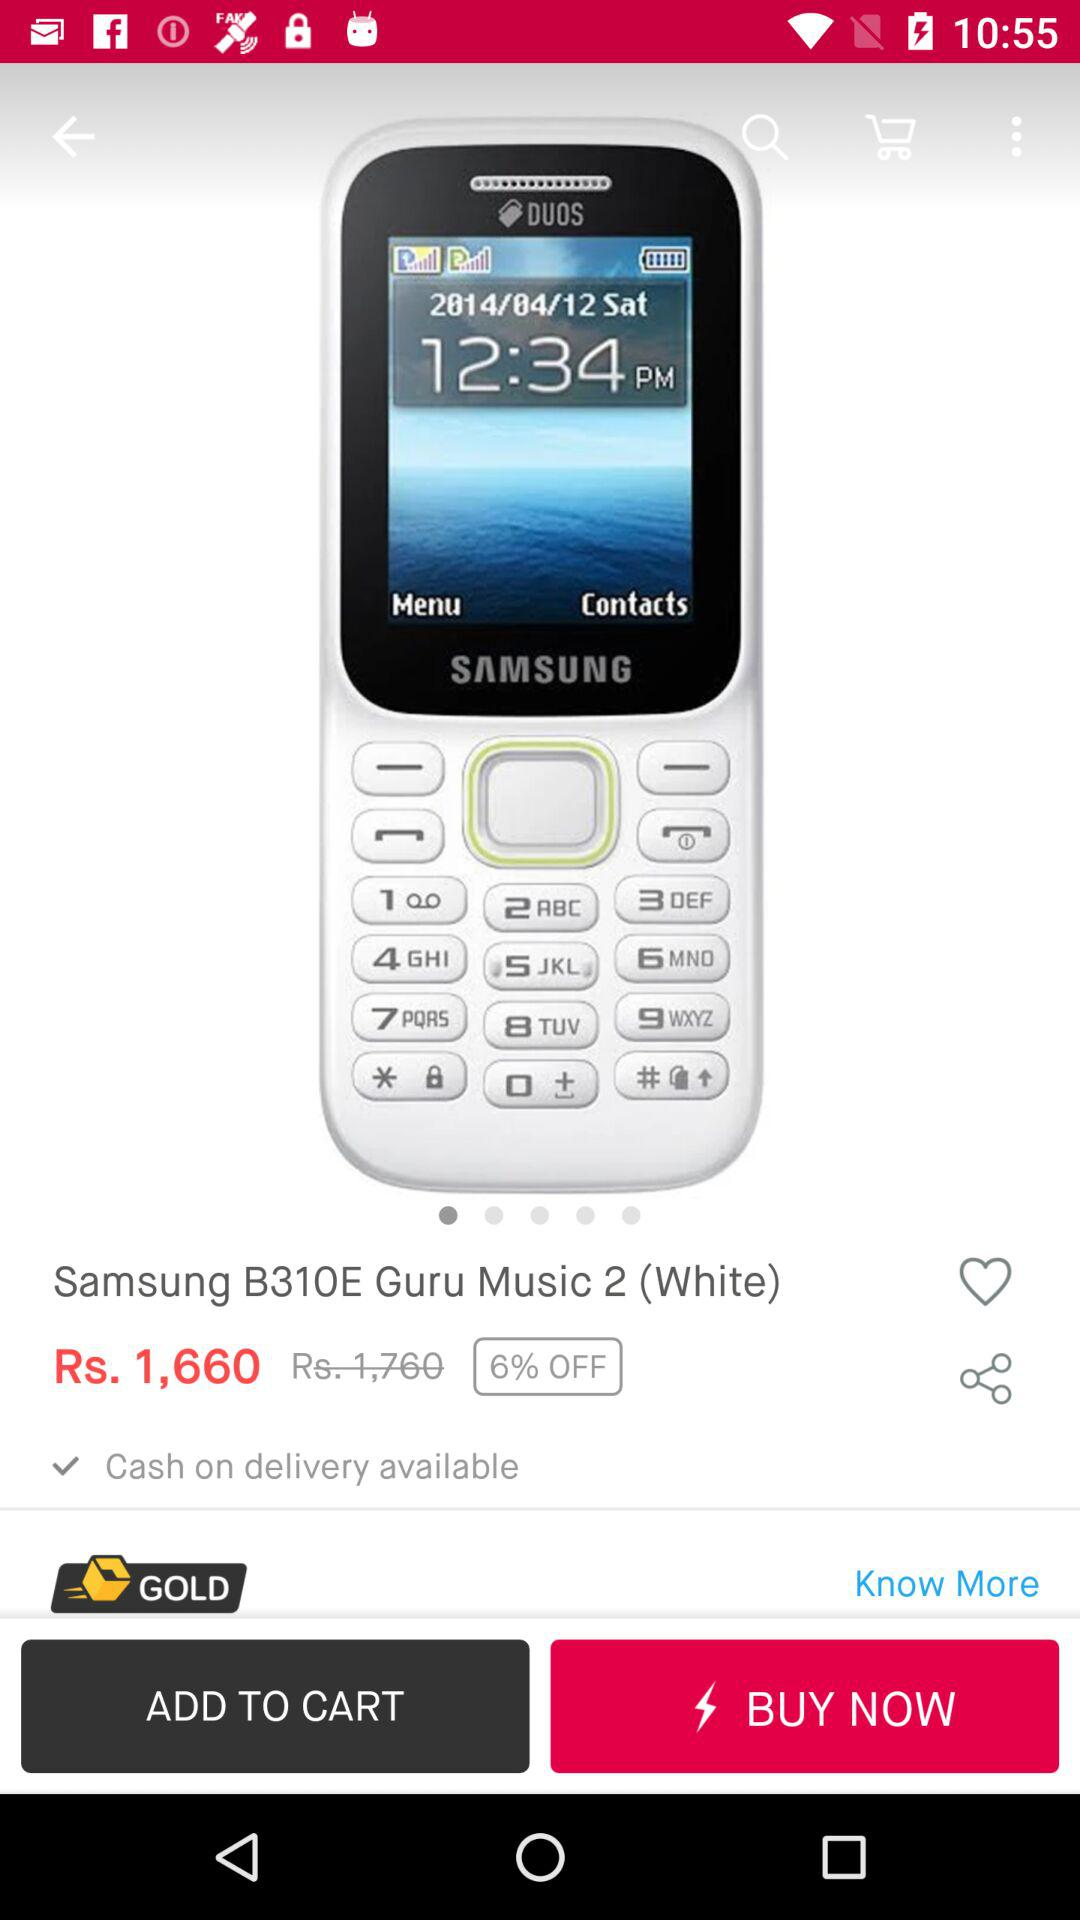How much is the discount on the phone?
Answer the question using a single word or phrase. 6% 